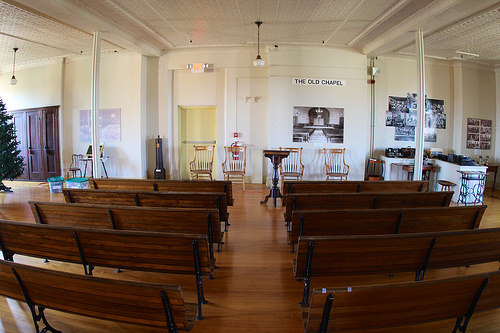<image>
Is there a christmas tree in front of the door? Yes. The christmas tree is positioned in front of the door, appearing closer to the camera viewpoint. 